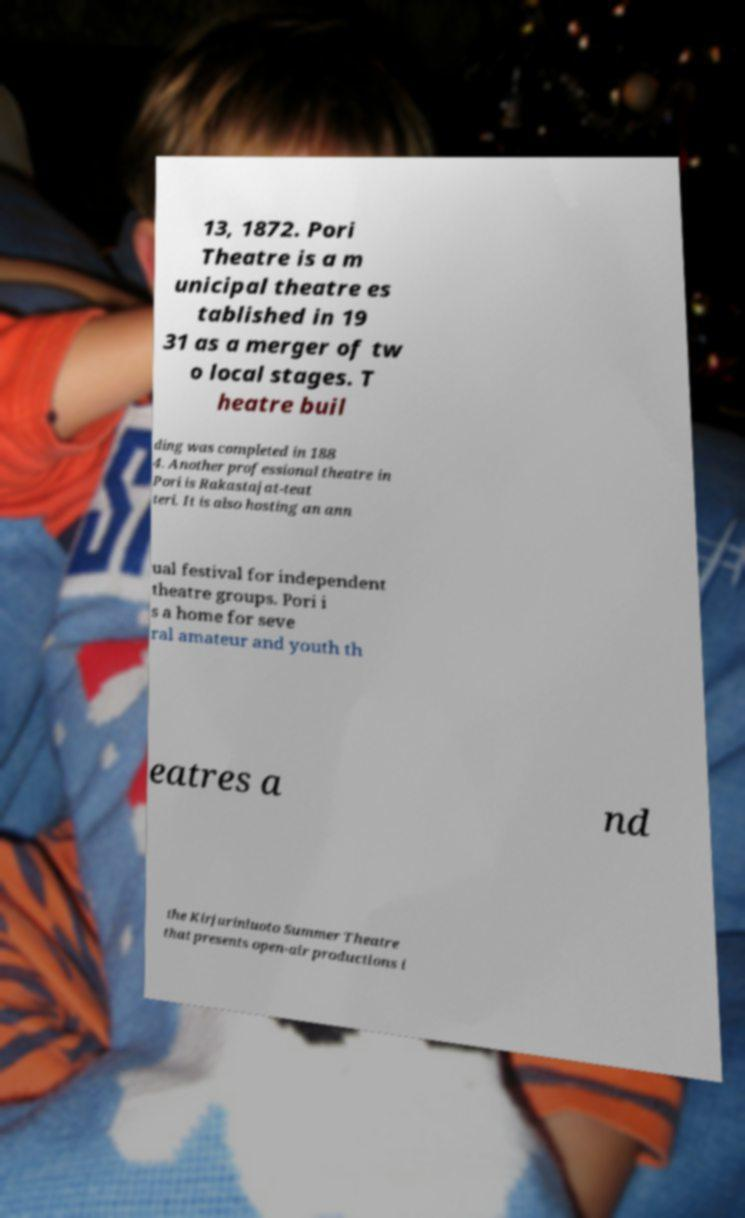Could you assist in decoding the text presented in this image and type it out clearly? 13, 1872. Pori Theatre is a m unicipal theatre es tablished in 19 31 as a merger of tw o local stages. T heatre buil ding was completed in 188 4. Another professional theatre in Pori is Rakastajat-teat teri. It is also hosting an ann ual festival for independent theatre groups. Pori i s a home for seve ral amateur and youth th eatres a nd the Kirjurinluoto Summer Theatre that presents open-air productions i 